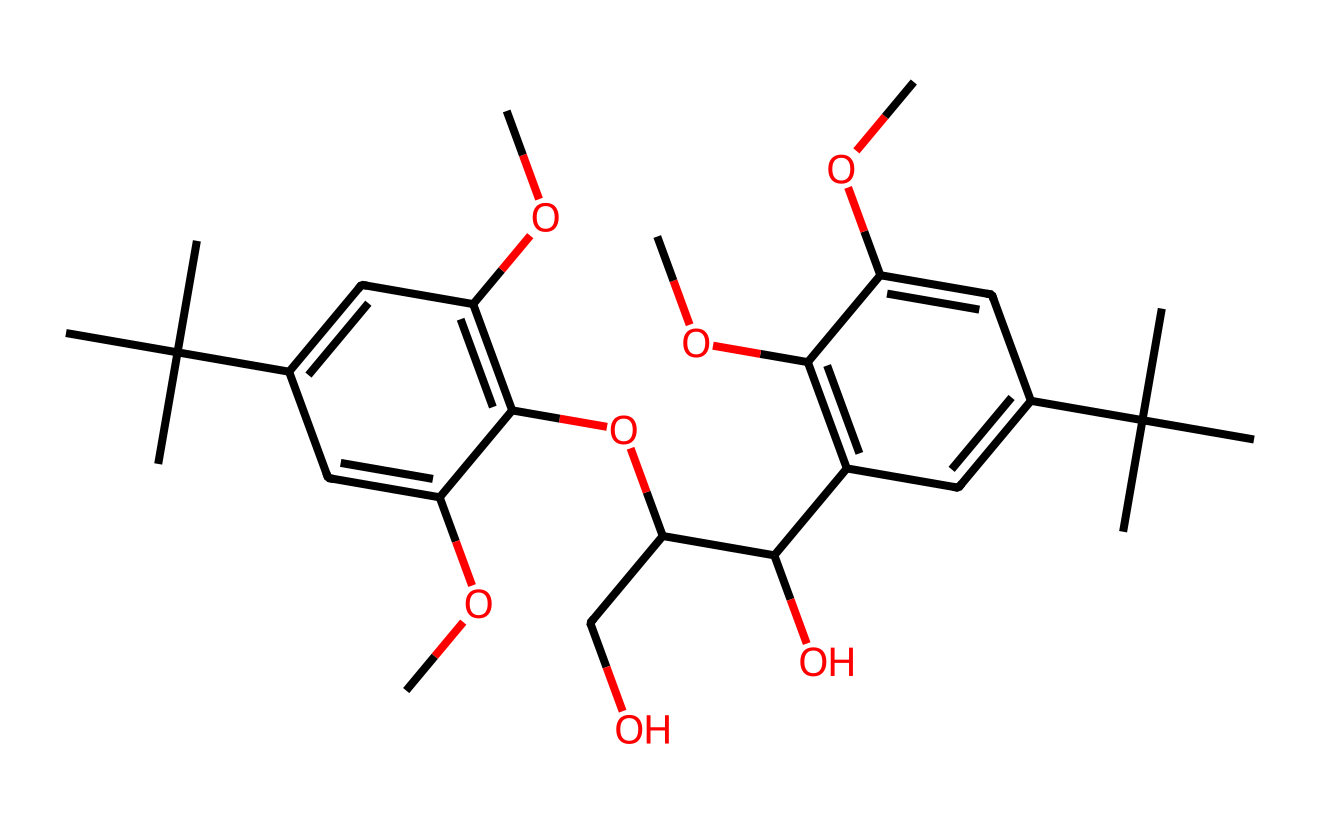how many carbon atoms are in the structure? Count the number of carbon atoms from the SMILES representation. Each "C" or "(C)" indicates a carbon atom, and tallying them gives the total. In this case, the total counts to 28 carbon atoms.
Answer: 28 what is the significance of the methoxy (–OCH3) groups in this photoresist? Methoxy groups can enhance the solubility of the resists in organic solvents and modify their photosensitivity. Their presence can indicate the potential for increased performance in lithographic applications.
Answer: enhance solubility how many hydroxyl (–OH) groups are in the compound? Identify hydroxyl groups in the structure represented by "C(O)" which indicates a carbon bonded to a hydroxyl group. Counting these in the SMILES shows there are three hydroxyl groups present.
Answer: 3 what type of molecular structure is represented by this chemical? The structure shows multiple conjugated systems due to the presence of carbon-carbon bonds and functional groups connected to aromatic rings, indicating its aromatic nature with characteristics typical of resists.
Answer: aromatic how does the structure indicate it is derived from renewable plant sources? The presence of methoxy groups and hydroxyl groups is common in plant-derived compounds, often suggesting they originate from biomass, and the overall complexity and natural-derived features reinforce its plant-based origin.
Answer: plant-derived what role does the aromatic ring play in this photoresist? The aromatic ring contributes to the stability and durability of the photoresist during the exposure and development process, making it integral for the functionality in lithographic applications.
Answer: stability 